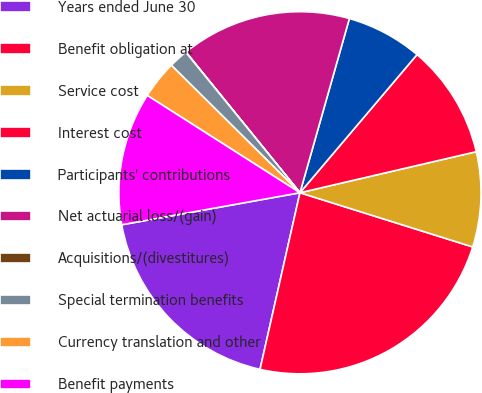Convert chart to OTSL. <chart><loc_0><loc_0><loc_500><loc_500><pie_chart><fcel>Years ended June 30<fcel>Benefit obligation at<fcel>Service cost<fcel>Interest cost<fcel>Participants' contributions<fcel>Net actuarial loss/(gain)<fcel>Acquisitions/(divestitures)<fcel>Special termination benefits<fcel>Currency translation and other<fcel>Benefit payments<nl><fcel>18.63%<fcel>23.7%<fcel>8.48%<fcel>10.17%<fcel>6.79%<fcel>15.24%<fcel>0.02%<fcel>1.71%<fcel>3.4%<fcel>11.86%<nl></chart> 